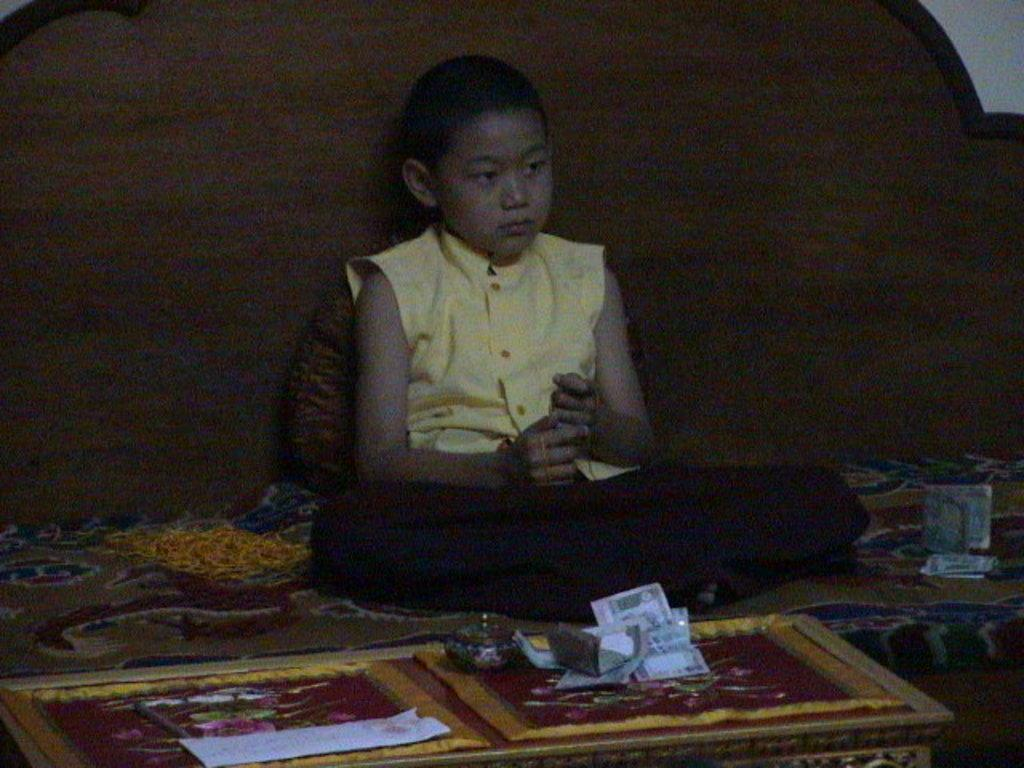Where was the image taken? The image was taken in a room. What is the boy doing in the image? The boy is sitting on a couch. What is in front of the boy? There is a table in front of the boy. What is on the table? Money is placed on the table. What can be seen in the background of the image? There is a wooden plank and a wall in the background. What type of cake is being served during the operation in the image? There is no cake or operation present in the image; it features a boy sitting on a couch with money on a table in a room. 